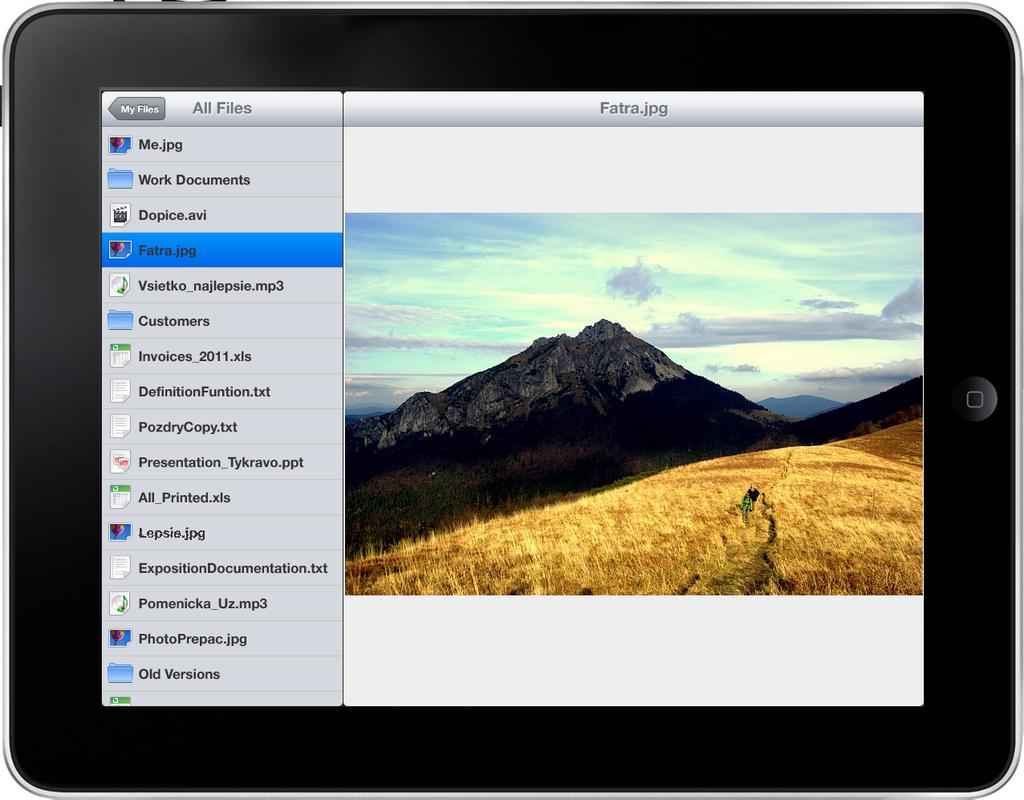What is the main object in the image? There is a gadget in the image. What elements are present within the gadget? The gadget contains fields, mountains, sky, and text. What type of trail can be seen winding through the mountains in the image? There is no trail visible in the image; the gadget contains only fields, mountains, sky, and text. 